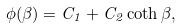<formula> <loc_0><loc_0><loc_500><loc_500>\phi ( \beta ) = C _ { 1 } + C _ { 2 } \coth \beta ,</formula> 